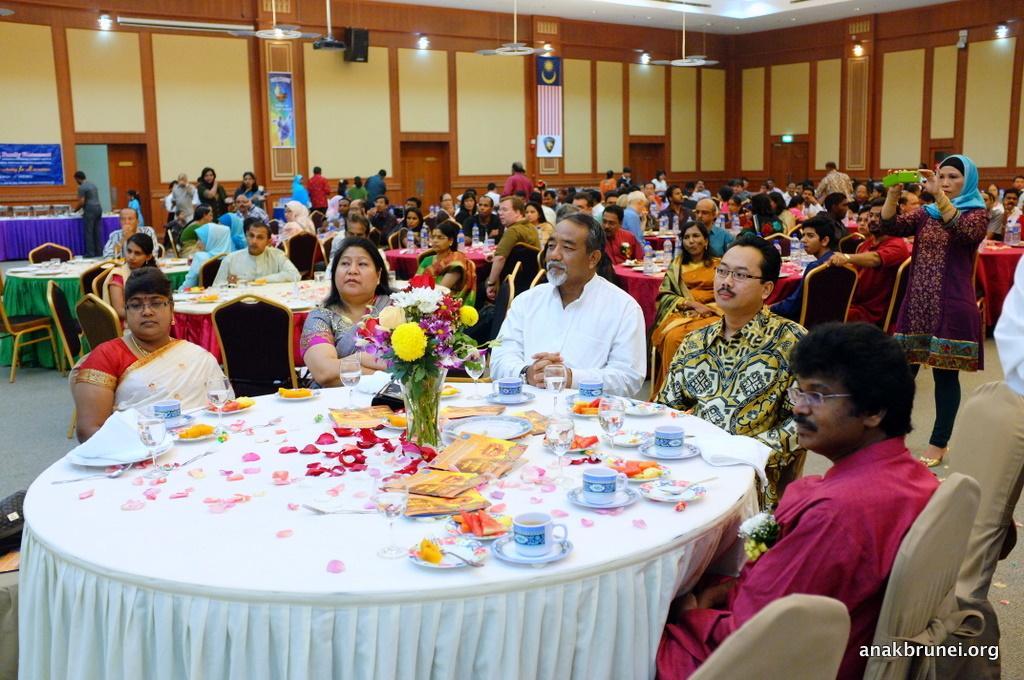Describe this image in one or two sentences. In the foreground of the image, we can see three men and two women are sitting on the chairs. In front of them, we can see a table. On the table, we can see cups, saucers, flowers, vase, flower petals, a bag and some objects. In the background, we can see so many people, tables and chairs. At the top of the image, we can see a wall, fans, lights and the roof. On the right side of the image, we can see a woman is standing. She is holding a mobile in her hand. There is a watermark in the right bottom of the image. 